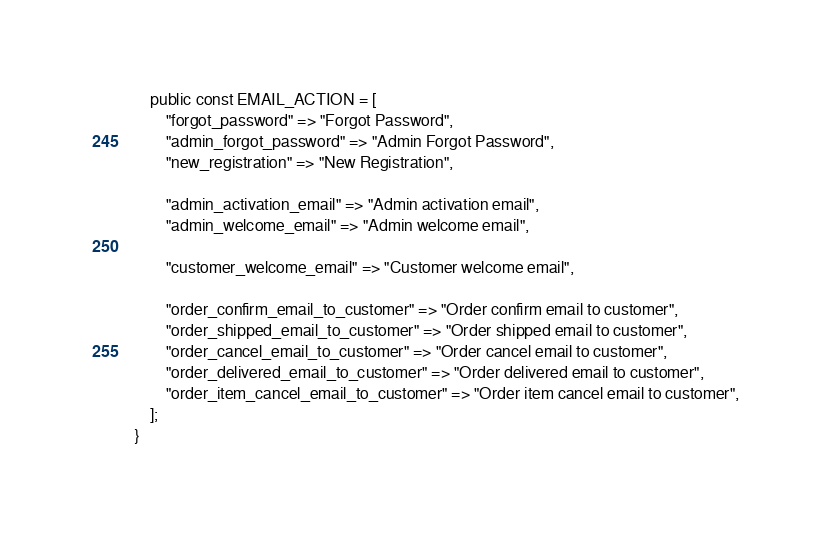<code> <loc_0><loc_0><loc_500><loc_500><_PHP_>
    public const EMAIL_ACTION = [
        "forgot_password" => "Forgot Password",
        "admin_forgot_password" => "Admin Forgot Password",
        "new_registration" => "New Registration",

        "admin_activation_email" => "Admin activation email",
        "admin_welcome_email" => "Admin welcome email",

        "customer_welcome_email" => "Customer welcome email",

        "order_confirm_email_to_customer" => "Order confirm email to customer",
        "order_shipped_email_to_customer" => "Order shipped email to customer",
        "order_cancel_email_to_customer" => "Order cancel email to customer",
        "order_delivered_email_to_customer" => "Order delivered email to customer",
        "order_item_cancel_email_to_customer" => "Order item cancel email to customer",
    ];
}
</code> 